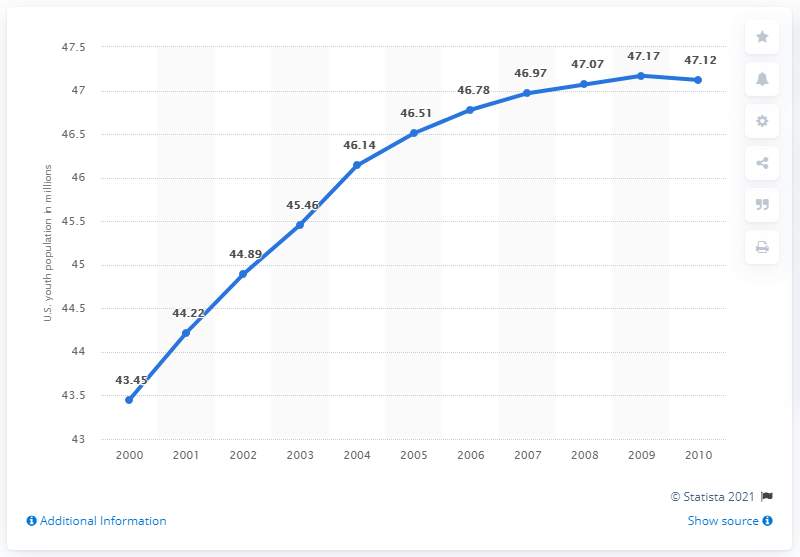Can you describe the trend in the young population from 2000 to 2010 shown in this chart? The chart displays a steady increase in the young population aged 14 to 24 in the United States from 2000 to 2010. The population grew from approximately 43.45 million in 2000 to 47.12 million in 2010. 